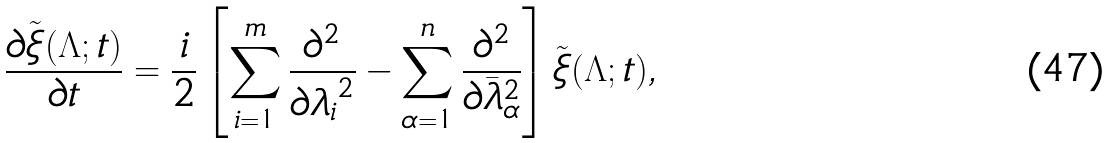<formula> <loc_0><loc_0><loc_500><loc_500>\frac { \partial \tilde { \xi } ( \Lambda ; t ) } { \partial t } = \frac { i } { 2 } \left [ \sum _ { i = 1 } ^ { m } \frac { \partial ^ { 2 } } { \partial { \lambda _ { i } } ^ { 2 } } - \sum _ { \alpha = 1 } ^ { n } \frac { \partial ^ { 2 } } { \partial { \bar { \lambda } } _ { \alpha } ^ { 2 } } \right ] \tilde { \xi } ( \Lambda ; t ) ,</formula> 